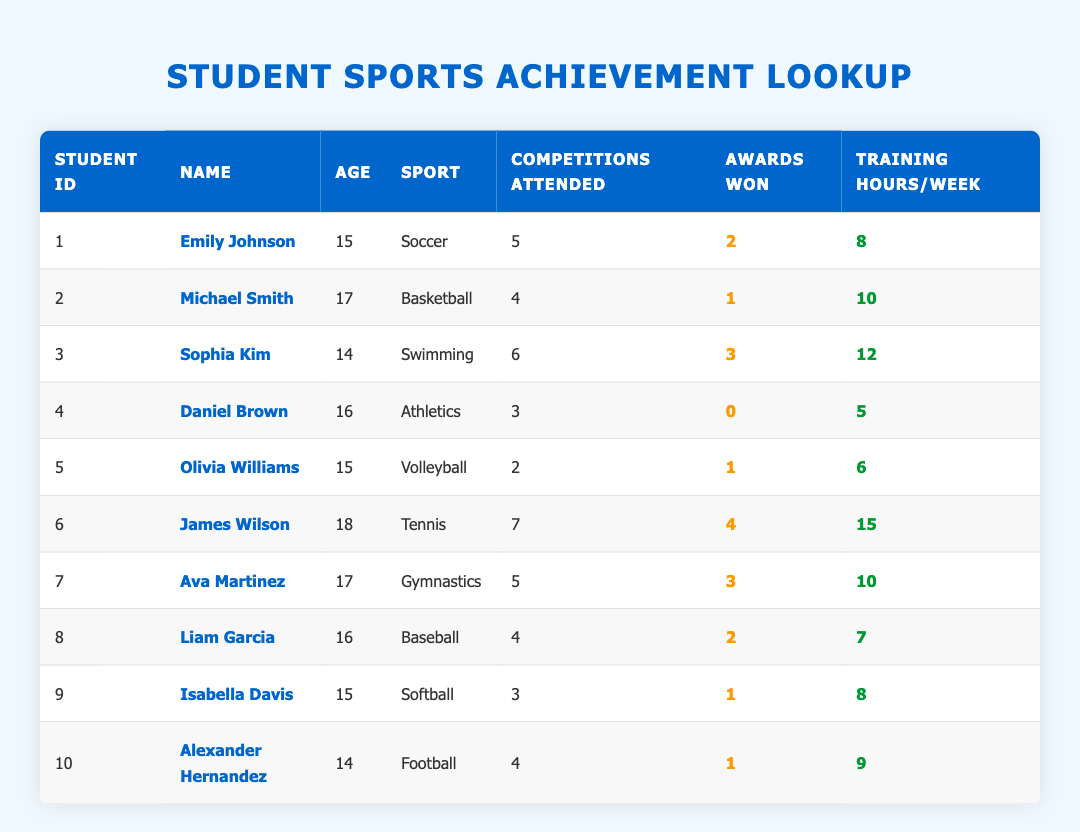What is the name of the student who attended the most competitions? Looking through the table, James Wilson attended 7 competitions, which is the highest attendance among all students.
Answer: James Wilson How many awards did Ava Martinez win? By checking the table, Ava Martinez won 3 awards, which is directly listed in her row.
Answer: 3 What is the total number of awards won by all the students combined? The awards won by each student are: 2, 1, 3, 0, 1, 4, 3, 2, 1, 1. Summing these gives: 2 + 1 + 3 + 0 + 1 + 4 + 3 + 2 + 1 + 1 = 18.
Answer: 18 Which sport has the highest number of training hours per week? Reviewing the training hours: Tennis has the highest with 15 hours per week (James Wilson). Other sports have 8, 10, 12, 5, 6, 10, 7, 8, and 9 hours.
Answer: Tennis Is there a student who did not win any awards? Yes, a review of the table shows Daniel Brown, who attended 3 competitions, has not won any awards, as marked by a "0" in his row.
Answer: Yes What is the average number of competitions attended by students aged 15? The students aged 15 are Emily Johnson, Olivia Williams, and Isabella Davis, who attended 5, 2, and 3 competitions respectively. The average is (5 + 2 + 3) / 3 = 10 / 3, which approximates to 3.33.
Answer: 3.33 How many students are involved in sports that won more than 1 award? The students with more than 1 award are Sophia Kim (3), James Wilson (4), and Ava Martinez (3). This totals to 3 students.
Answer: 3 Which student has the lowest number of training hours per week? In the table, Daniel Brown has the lowest training hours, recorded at 5 hours per week, compared to others.
Answer: Daniel Brown How many students participated in soccer and basketball combined? From the table, only Emily Johnson participates in soccer and Michael Smith in basketball. Therefore, the total number of participants is 2.
Answer: 2 